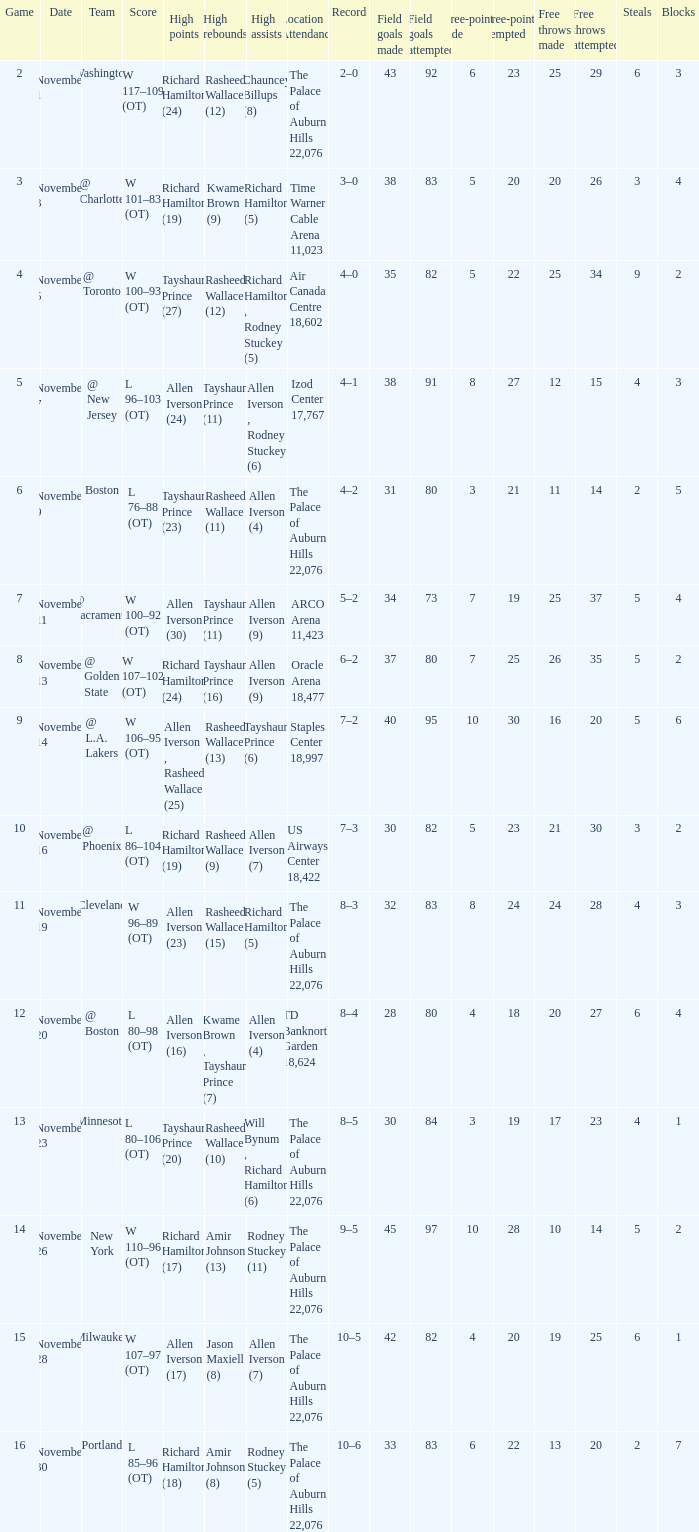What is the geographic attendance, when top points is "allen iverson (23)"? The Palace of Auburn Hills 22,076. 